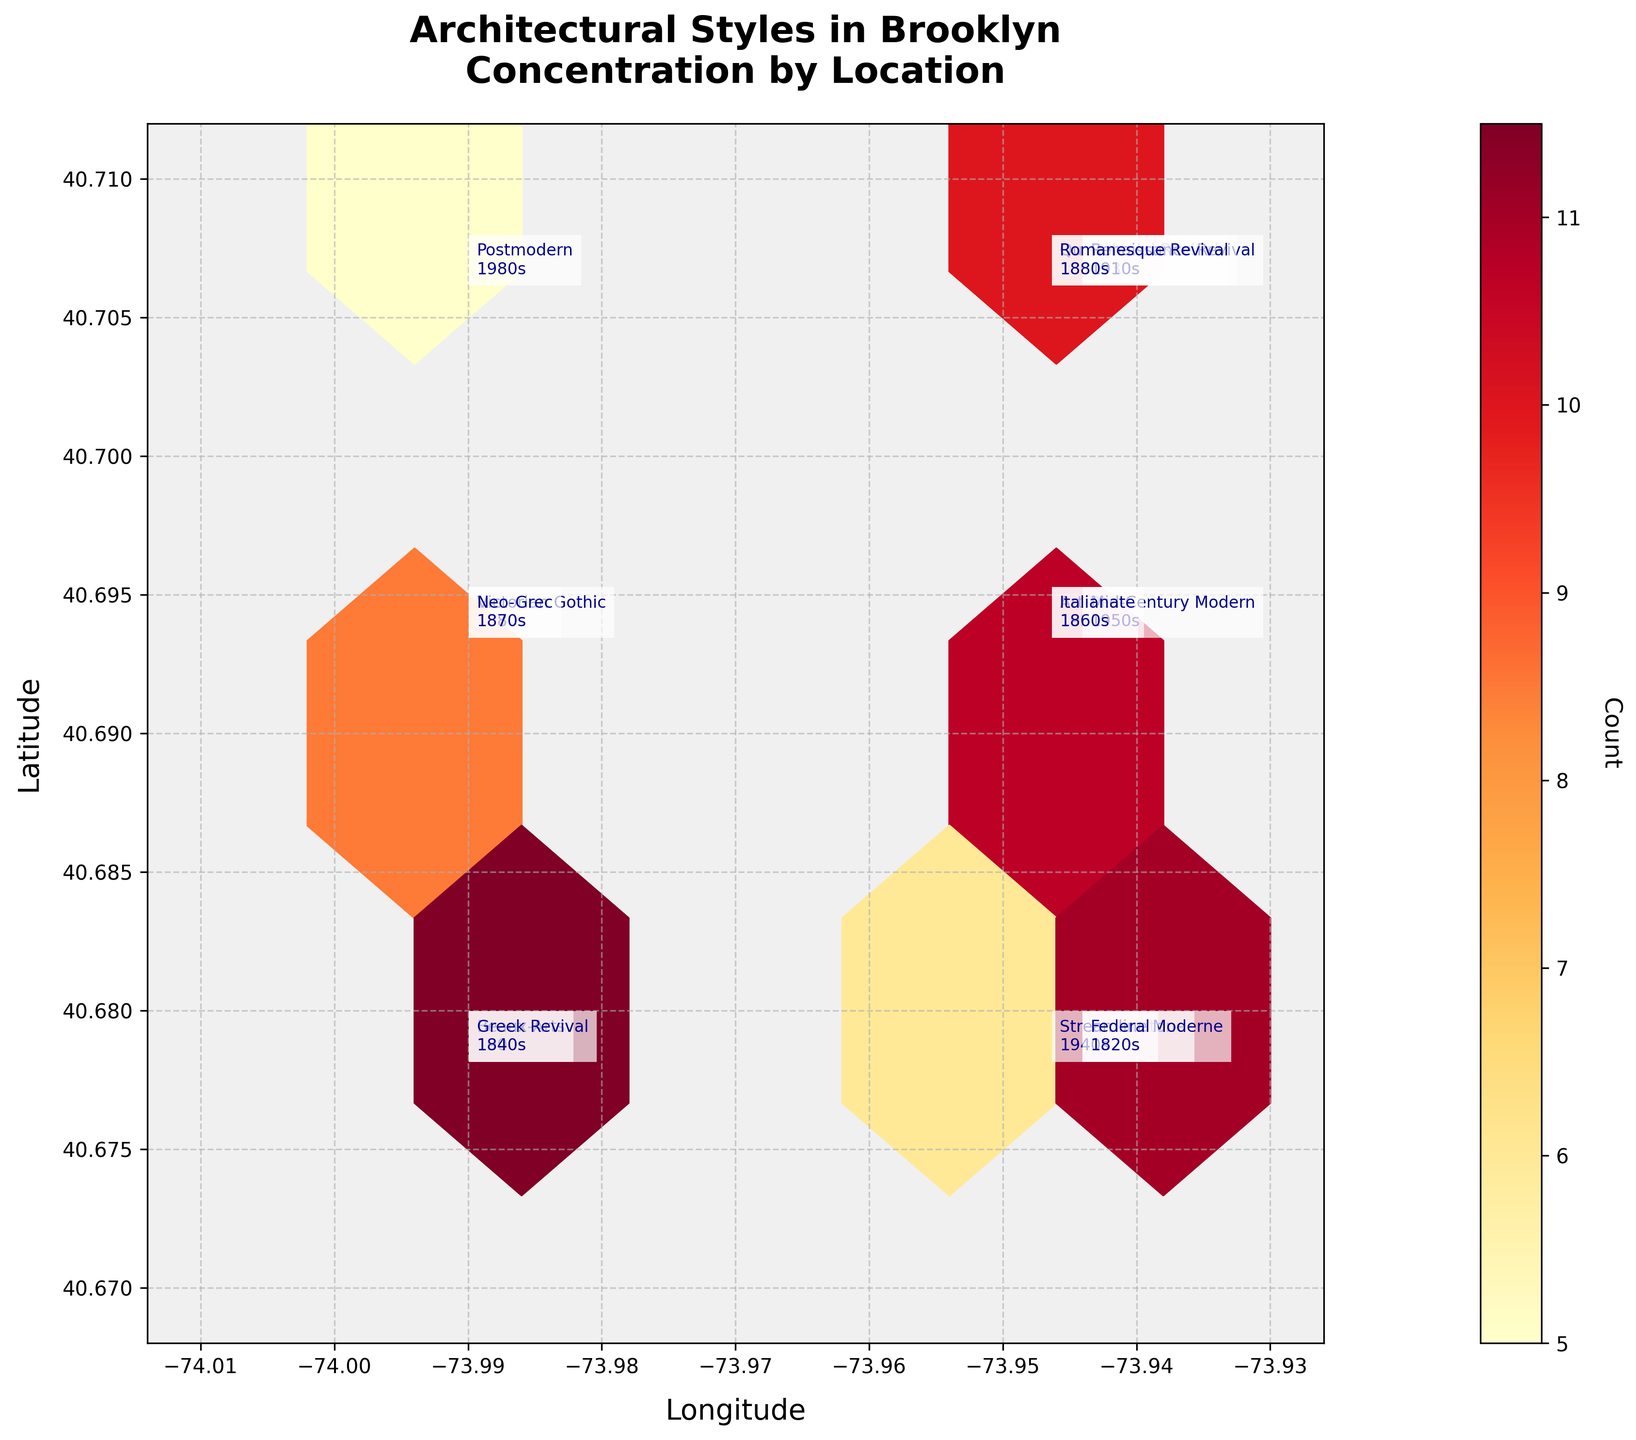What is the title of the plot? The title of the plot is located at the top of the figure.
Answer: Architectural Styles in Brooklyn: Concentration by Location Which architectural style appears on the plot from the 1880s? There are two architectural styles from the 1880s, annotated on the plot with their names and decades.
Answer: Victorian Gothic and Romanesque Revival How many architectural styles are located around longitude -73.9442 and latitude 40.6782? Observe the figure annotations at the coordinates near longitude -73.9442 and latitude 40.6782 to list the different architectural styles presented there.
Answer: Two (Brownstone and Federal) Which decade is represented by the Postmodern style, and how many buildings of this style are there? Check the annotated text next to the Postmodern style to find its decade and count.
Answer: 1980s, 5 buildings Comparing the count of Art Deco and Mid-Century Modern styles, which has more buildings and by how many? Locate the annotations for Art Deco and Mid-Century Modern styles on the plot, and subtract the count of Art Deco from that of Mid-Century Modern.
Answer: Mid-Century Modern by 4 buildings What color scale is used to represent the count of buildings in the hexbin plot? Observing the colorbar on the plot, which is labeled Count, will show the color scale used.
Answer: YlOrRd Which decade has the highest count of buildings and what are they? Observe each annotated decade and its count on the plot to determine which has the highest count and its architectural styles.
Answer: 1870s, Brownstone and Neo-Grec If you add the number of buildings from the styles of both the 1840s and 1860s, what is the total? Find and sum the count of Greek Revival from the 1840s and Italianate from the 1860s.
Answer: 27 buildings How does the spatial distribution of Federal style compare to Renaissance Revival? Observing their locations on the plot, Federal style is on the south-east corner while Renaissance Revival is on the north-east.
Answer: Federal in the south-east, Renaissance Revival in the north-east 